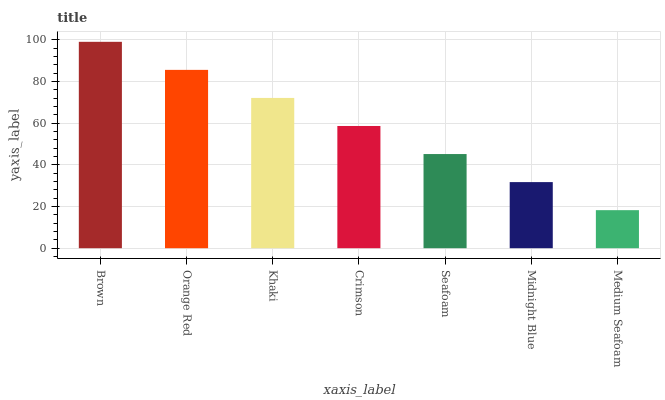Is Medium Seafoam the minimum?
Answer yes or no. Yes. Is Brown the maximum?
Answer yes or no. Yes. Is Orange Red the minimum?
Answer yes or no. No. Is Orange Red the maximum?
Answer yes or no. No. Is Brown greater than Orange Red?
Answer yes or no. Yes. Is Orange Red less than Brown?
Answer yes or no. Yes. Is Orange Red greater than Brown?
Answer yes or no. No. Is Brown less than Orange Red?
Answer yes or no. No. Is Crimson the high median?
Answer yes or no. Yes. Is Crimson the low median?
Answer yes or no. Yes. Is Brown the high median?
Answer yes or no. No. Is Seafoam the low median?
Answer yes or no. No. 